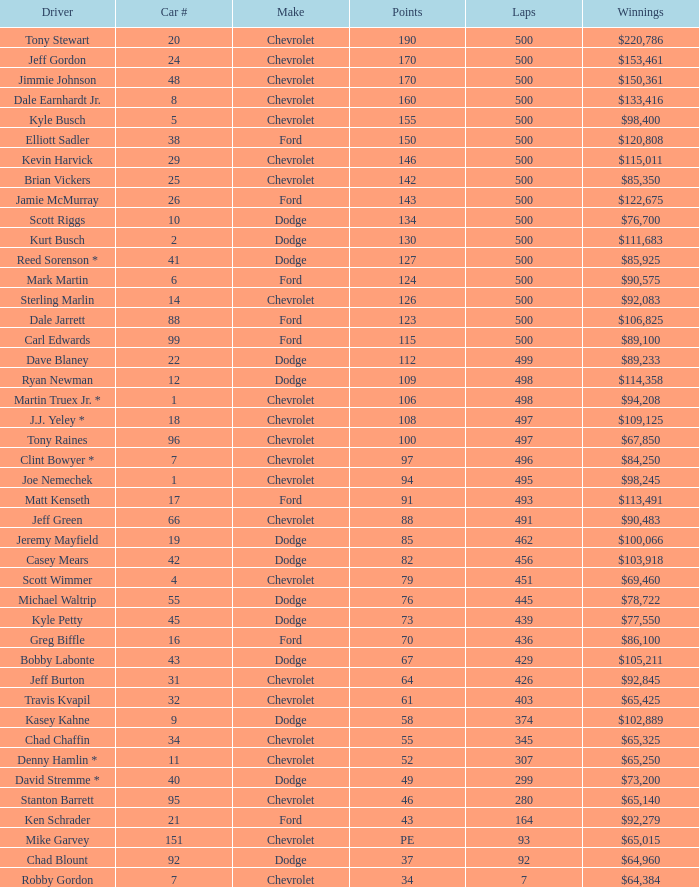Could you parse the entire table? {'header': ['Driver', 'Car #', 'Make', 'Points', 'Laps', 'Winnings'], 'rows': [['Tony Stewart', '20', 'Chevrolet', '190', '500', '$220,786'], ['Jeff Gordon', '24', 'Chevrolet', '170', '500', '$153,461'], ['Jimmie Johnson', '48', 'Chevrolet', '170', '500', '$150,361'], ['Dale Earnhardt Jr.', '8', 'Chevrolet', '160', '500', '$133,416'], ['Kyle Busch', '5', 'Chevrolet', '155', '500', '$98,400'], ['Elliott Sadler', '38', 'Ford', '150', '500', '$120,808'], ['Kevin Harvick', '29', 'Chevrolet', '146', '500', '$115,011'], ['Brian Vickers', '25', 'Chevrolet', '142', '500', '$85,350'], ['Jamie McMurray', '26', 'Ford', '143', '500', '$122,675'], ['Scott Riggs', '10', 'Dodge', '134', '500', '$76,700'], ['Kurt Busch', '2', 'Dodge', '130', '500', '$111,683'], ['Reed Sorenson *', '41', 'Dodge', '127', '500', '$85,925'], ['Mark Martin', '6', 'Ford', '124', '500', '$90,575'], ['Sterling Marlin', '14', 'Chevrolet', '126', '500', '$92,083'], ['Dale Jarrett', '88', 'Ford', '123', '500', '$106,825'], ['Carl Edwards', '99', 'Ford', '115', '500', '$89,100'], ['Dave Blaney', '22', 'Dodge', '112', '499', '$89,233'], ['Ryan Newman', '12', 'Dodge', '109', '498', '$114,358'], ['Martin Truex Jr. *', '1', 'Chevrolet', '106', '498', '$94,208'], ['J.J. Yeley *', '18', 'Chevrolet', '108', '497', '$109,125'], ['Tony Raines', '96', 'Chevrolet', '100', '497', '$67,850'], ['Clint Bowyer *', '7', 'Chevrolet', '97', '496', '$84,250'], ['Joe Nemechek', '1', 'Chevrolet', '94', '495', '$98,245'], ['Matt Kenseth', '17', 'Ford', '91', '493', '$113,491'], ['Jeff Green', '66', 'Chevrolet', '88', '491', '$90,483'], ['Jeremy Mayfield', '19', 'Dodge', '85', '462', '$100,066'], ['Casey Mears', '42', 'Dodge', '82', '456', '$103,918'], ['Scott Wimmer', '4', 'Chevrolet', '79', '451', '$69,460'], ['Michael Waltrip', '55', 'Dodge', '76', '445', '$78,722'], ['Kyle Petty', '45', 'Dodge', '73', '439', '$77,550'], ['Greg Biffle', '16', 'Ford', '70', '436', '$86,100'], ['Bobby Labonte', '43', 'Dodge', '67', '429', '$105,211'], ['Jeff Burton', '31', 'Chevrolet', '64', '426', '$92,845'], ['Travis Kvapil', '32', 'Chevrolet', '61', '403', '$65,425'], ['Kasey Kahne', '9', 'Dodge', '58', '374', '$102,889'], ['Chad Chaffin', '34', 'Chevrolet', '55', '345', '$65,325'], ['Denny Hamlin *', '11', 'Chevrolet', '52', '307', '$65,250'], ['David Stremme *', '40', 'Dodge', '49', '299', '$73,200'], ['Stanton Barrett', '95', 'Chevrolet', '46', '280', '$65,140'], ['Ken Schrader', '21', 'Ford', '43', '164', '$92,279'], ['Mike Garvey', '151', 'Chevrolet', 'PE', '93', '$65,015'], ['Chad Blount', '92', 'Dodge', '37', '92', '$64,960'], ['Robby Gordon', '7', 'Chevrolet', '34', '7', '$64,384']]} What is the median car number of all the drivers with 109 points? 12.0. 